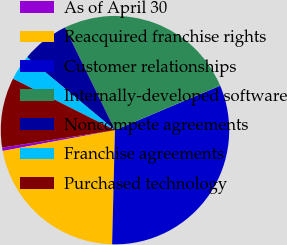Convert chart to OTSL. <chart><loc_0><loc_0><loc_500><loc_500><pie_chart><fcel>As of April 30<fcel>Reacquired franchise rights<fcel>Customer relationships<fcel>Internally-developed software<fcel>Noncompete agreements<fcel>Franchise agreements<fcel>Purchased technology<nl><fcel>0.48%<fcel>21.68%<fcel>31.77%<fcel>25.85%<fcel>6.74%<fcel>3.61%<fcel>9.87%<nl></chart> 